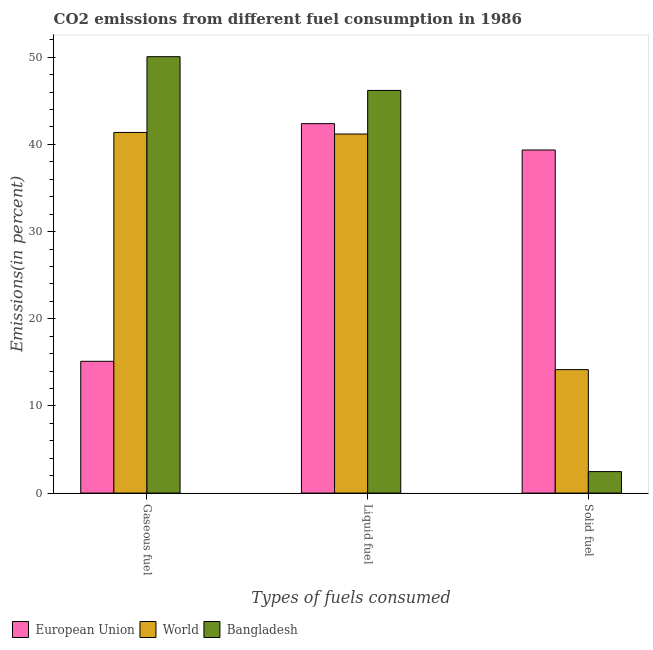How many groups of bars are there?
Give a very brief answer. 3. Are the number of bars per tick equal to the number of legend labels?
Provide a succinct answer. Yes. What is the label of the 1st group of bars from the left?
Make the answer very short. Gaseous fuel. What is the percentage of gaseous fuel emission in European Union?
Make the answer very short. 15.12. Across all countries, what is the maximum percentage of gaseous fuel emission?
Provide a short and direct response. 50.06. Across all countries, what is the minimum percentage of gaseous fuel emission?
Provide a short and direct response. 15.12. In which country was the percentage of gaseous fuel emission maximum?
Offer a terse response. Bangladesh. In which country was the percentage of liquid fuel emission minimum?
Offer a terse response. World. What is the total percentage of gaseous fuel emission in the graph?
Make the answer very short. 106.55. What is the difference between the percentage of solid fuel emission in World and that in European Union?
Ensure brevity in your answer.  -25.2. What is the difference between the percentage of gaseous fuel emission in World and the percentage of solid fuel emission in Bangladesh?
Offer a very short reply. 38.91. What is the average percentage of gaseous fuel emission per country?
Give a very brief answer. 35.52. What is the difference between the percentage of liquid fuel emission and percentage of solid fuel emission in European Union?
Offer a terse response. 3.02. In how many countries, is the percentage of solid fuel emission greater than 38 %?
Make the answer very short. 1. What is the ratio of the percentage of gaseous fuel emission in Bangladesh to that in World?
Provide a short and direct response. 1.21. Is the percentage of liquid fuel emission in World less than that in European Union?
Keep it short and to the point. Yes. Is the difference between the percentage of liquid fuel emission in Bangladesh and World greater than the difference between the percentage of gaseous fuel emission in Bangladesh and World?
Offer a very short reply. No. What is the difference between the highest and the second highest percentage of gaseous fuel emission?
Ensure brevity in your answer.  8.69. What is the difference between the highest and the lowest percentage of gaseous fuel emission?
Provide a short and direct response. 34.95. In how many countries, is the percentage of solid fuel emission greater than the average percentage of solid fuel emission taken over all countries?
Your answer should be compact. 1. Is the sum of the percentage of liquid fuel emission in World and Bangladesh greater than the maximum percentage of solid fuel emission across all countries?
Ensure brevity in your answer.  Yes. What does the 2nd bar from the left in Solid fuel represents?
Provide a short and direct response. World. What does the 2nd bar from the right in Gaseous fuel represents?
Give a very brief answer. World. How many bars are there?
Your answer should be very brief. 9. Are all the bars in the graph horizontal?
Offer a very short reply. No. What is the difference between two consecutive major ticks on the Y-axis?
Your answer should be very brief. 10. Are the values on the major ticks of Y-axis written in scientific E-notation?
Your response must be concise. No. Does the graph contain any zero values?
Offer a terse response. No. Does the graph contain grids?
Offer a very short reply. No. Where does the legend appear in the graph?
Your answer should be compact. Bottom left. How many legend labels are there?
Your response must be concise. 3. How are the legend labels stacked?
Offer a terse response. Horizontal. What is the title of the graph?
Your answer should be compact. CO2 emissions from different fuel consumption in 1986. Does "Poland" appear as one of the legend labels in the graph?
Your response must be concise. No. What is the label or title of the X-axis?
Ensure brevity in your answer.  Types of fuels consumed. What is the label or title of the Y-axis?
Your answer should be compact. Emissions(in percent). What is the Emissions(in percent) in European Union in Gaseous fuel?
Offer a terse response. 15.12. What is the Emissions(in percent) in World in Gaseous fuel?
Make the answer very short. 41.37. What is the Emissions(in percent) in Bangladesh in Gaseous fuel?
Give a very brief answer. 50.06. What is the Emissions(in percent) in European Union in Liquid fuel?
Your response must be concise. 42.38. What is the Emissions(in percent) in World in Liquid fuel?
Make the answer very short. 41.19. What is the Emissions(in percent) of Bangladesh in Liquid fuel?
Your response must be concise. 46.19. What is the Emissions(in percent) of European Union in Solid fuel?
Offer a terse response. 39.36. What is the Emissions(in percent) of World in Solid fuel?
Give a very brief answer. 14.16. What is the Emissions(in percent) in Bangladesh in Solid fuel?
Your response must be concise. 2.46. Across all Types of fuels consumed, what is the maximum Emissions(in percent) in European Union?
Your answer should be very brief. 42.38. Across all Types of fuels consumed, what is the maximum Emissions(in percent) of World?
Your answer should be very brief. 41.37. Across all Types of fuels consumed, what is the maximum Emissions(in percent) in Bangladesh?
Keep it short and to the point. 50.06. Across all Types of fuels consumed, what is the minimum Emissions(in percent) in European Union?
Give a very brief answer. 15.12. Across all Types of fuels consumed, what is the minimum Emissions(in percent) in World?
Ensure brevity in your answer.  14.16. Across all Types of fuels consumed, what is the minimum Emissions(in percent) in Bangladesh?
Offer a terse response. 2.46. What is the total Emissions(in percent) of European Union in the graph?
Offer a very short reply. 96.86. What is the total Emissions(in percent) in World in the graph?
Keep it short and to the point. 96.73. What is the total Emissions(in percent) of Bangladesh in the graph?
Ensure brevity in your answer.  98.72. What is the difference between the Emissions(in percent) in European Union in Gaseous fuel and that in Liquid fuel?
Offer a terse response. -27.27. What is the difference between the Emissions(in percent) in World in Gaseous fuel and that in Liquid fuel?
Keep it short and to the point. 0.18. What is the difference between the Emissions(in percent) of Bangladesh in Gaseous fuel and that in Liquid fuel?
Provide a succinct answer. 3.87. What is the difference between the Emissions(in percent) in European Union in Gaseous fuel and that in Solid fuel?
Give a very brief answer. -24.24. What is the difference between the Emissions(in percent) of World in Gaseous fuel and that in Solid fuel?
Your response must be concise. 27.21. What is the difference between the Emissions(in percent) of Bangladesh in Gaseous fuel and that in Solid fuel?
Your answer should be very brief. 47.6. What is the difference between the Emissions(in percent) in European Union in Liquid fuel and that in Solid fuel?
Offer a terse response. 3.02. What is the difference between the Emissions(in percent) in World in Liquid fuel and that in Solid fuel?
Your answer should be very brief. 27.03. What is the difference between the Emissions(in percent) of Bangladesh in Liquid fuel and that in Solid fuel?
Make the answer very short. 43.73. What is the difference between the Emissions(in percent) of European Union in Gaseous fuel and the Emissions(in percent) of World in Liquid fuel?
Provide a succinct answer. -26.07. What is the difference between the Emissions(in percent) in European Union in Gaseous fuel and the Emissions(in percent) in Bangladesh in Liquid fuel?
Your answer should be very brief. -31.08. What is the difference between the Emissions(in percent) in World in Gaseous fuel and the Emissions(in percent) in Bangladesh in Liquid fuel?
Your answer should be very brief. -4.82. What is the difference between the Emissions(in percent) of European Union in Gaseous fuel and the Emissions(in percent) of World in Solid fuel?
Offer a terse response. 0.95. What is the difference between the Emissions(in percent) in European Union in Gaseous fuel and the Emissions(in percent) in Bangladesh in Solid fuel?
Provide a short and direct response. 12.65. What is the difference between the Emissions(in percent) in World in Gaseous fuel and the Emissions(in percent) in Bangladesh in Solid fuel?
Provide a succinct answer. 38.91. What is the difference between the Emissions(in percent) in European Union in Liquid fuel and the Emissions(in percent) in World in Solid fuel?
Keep it short and to the point. 28.22. What is the difference between the Emissions(in percent) of European Union in Liquid fuel and the Emissions(in percent) of Bangladesh in Solid fuel?
Give a very brief answer. 39.92. What is the difference between the Emissions(in percent) of World in Liquid fuel and the Emissions(in percent) of Bangladesh in Solid fuel?
Offer a very short reply. 38.73. What is the average Emissions(in percent) of European Union per Types of fuels consumed?
Give a very brief answer. 32.29. What is the average Emissions(in percent) of World per Types of fuels consumed?
Provide a succinct answer. 32.24. What is the average Emissions(in percent) in Bangladesh per Types of fuels consumed?
Provide a short and direct response. 32.91. What is the difference between the Emissions(in percent) of European Union and Emissions(in percent) of World in Gaseous fuel?
Give a very brief answer. -26.26. What is the difference between the Emissions(in percent) in European Union and Emissions(in percent) in Bangladesh in Gaseous fuel?
Ensure brevity in your answer.  -34.95. What is the difference between the Emissions(in percent) in World and Emissions(in percent) in Bangladesh in Gaseous fuel?
Make the answer very short. -8.69. What is the difference between the Emissions(in percent) of European Union and Emissions(in percent) of World in Liquid fuel?
Give a very brief answer. 1.19. What is the difference between the Emissions(in percent) in European Union and Emissions(in percent) in Bangladesh in Liquid fuel?
Provide a short and direct response. -3.81. What is the difference between the Emissions(in percent) in World and Emissions(in percent) in Bangladesh in Liquid fuel?
Make the answer very short. -5. What is the difference between the Emissions(in percent) in European Union and Emissions(in percent) in World in Solid fuel?
Make the answer very short. 25.2. What is the difference between the Emissions(in percent) in European Union and Emissions(in percent) in Bangladesh in Solid fuel?
Ensure brevity in your answer.  36.9. What is the difference between the Emissions(in percent) in World and Emissions(in percent) in Bangladesh in Solid fuel?
Provide a short and direct response. 11.7. What is the ratio of the Emissions(in percent) in European Union in Gaseous fuel to that in Liquid fuel?
Your answer should be compact. 0.36. What is the ratio of the Emissions(in percent) in World in Gaseous fuel to that in Liquid fuel?
Your answer should be very brief. 1. What is the ratio of the Emissions(in percent) in Bangladesh in Gaseous fuel to that in Liquid fuel?
Ensure brevity in your answer.  1.08. What is the ratio of the Emissions(in percent) in European Union in Gaseous fuel to that in Solid fuel?
Give a very brief answer. 0.38. What is the ratio of the Emissions(in percent) of World in Gaseous fuel to that in Solid fuel?
Provide a short and direct response. 2.92. What is the ratio of the Emissions(in percent) in Bangladesh in Gaseous fuel to that in Solid fuel?
Keep it short and to the point. 20.32. What is the ratio of the Emissions(in percent) of European Union in Liquid fuel to that in Solid fuel?
Your answer should be very brief. 1.08. What is the ratio of the Emissions(in percent) of World in Liquid fuel to that in Solid fuel?
Provide a short and direct response. 2.91. What is the ratio of the Emissions(in percent) of Bangladesh in Liquid fuel to that in Solid fuel?
Give a very brief answer. 18.75. What is the difference between the highest and the second highest Emissions(in percent) in European Union?
Your answer should be compact. 3.02. What is the difference between the highest and the second highest Emissions(in percent) in World?
Your answer should be very brief. 0.18. What is the difference between the highest and the second highest Emissions(in percent) in Bangladesh?
Give a very brief answer. 3.87. What is the difference between the highest and the lowest Emissions(in percent) of European Union?
Offer a very short reply. 27.27. What is the difference between the highest and the lowest Emissions(in percent) of World?
Your response must be concise. 27.21. What is the difference between the highest and the lowest Emissions(in percent) in Bangladesh?
Your answer should be very brief. 47.6. 